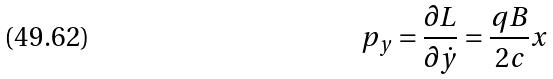Convert formula to latex. <formula><loc_0><loc_0><loc_500><loc_500>p _ { y } = \frac { \partial L } { \partial \dot { y } } = \frac { q B } { 2 c } x</formula> 